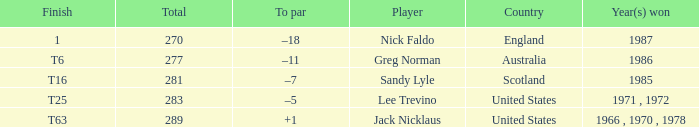How many totals have t6 as the finish? 277.0. 